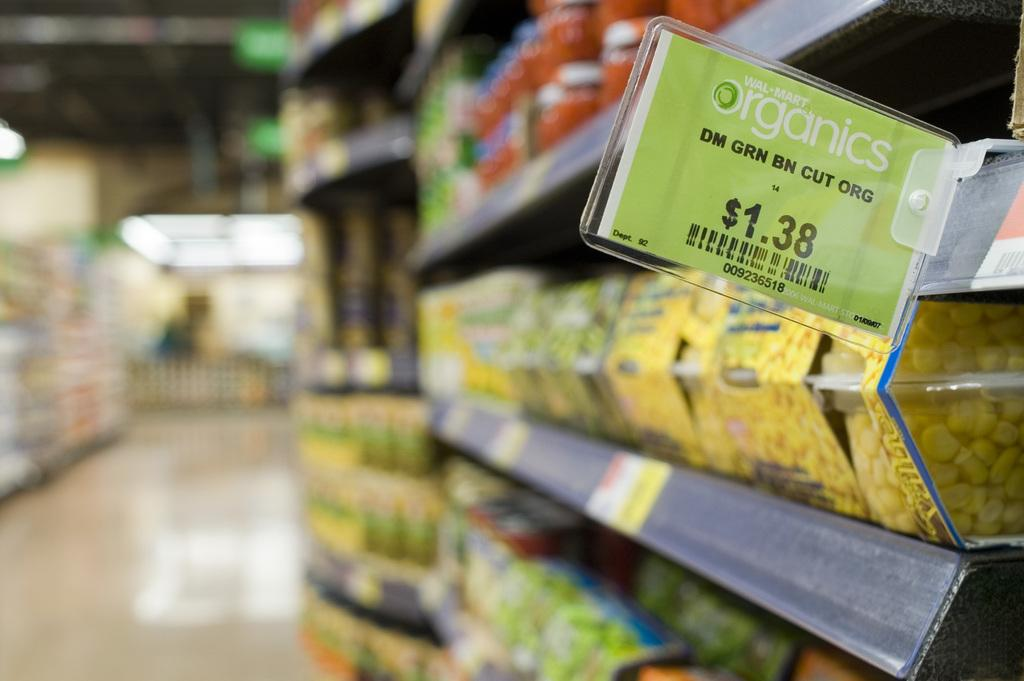<image>
Relay a brief, clear account of the picture shown. A supermarket shelf which has the word Organics visible. 